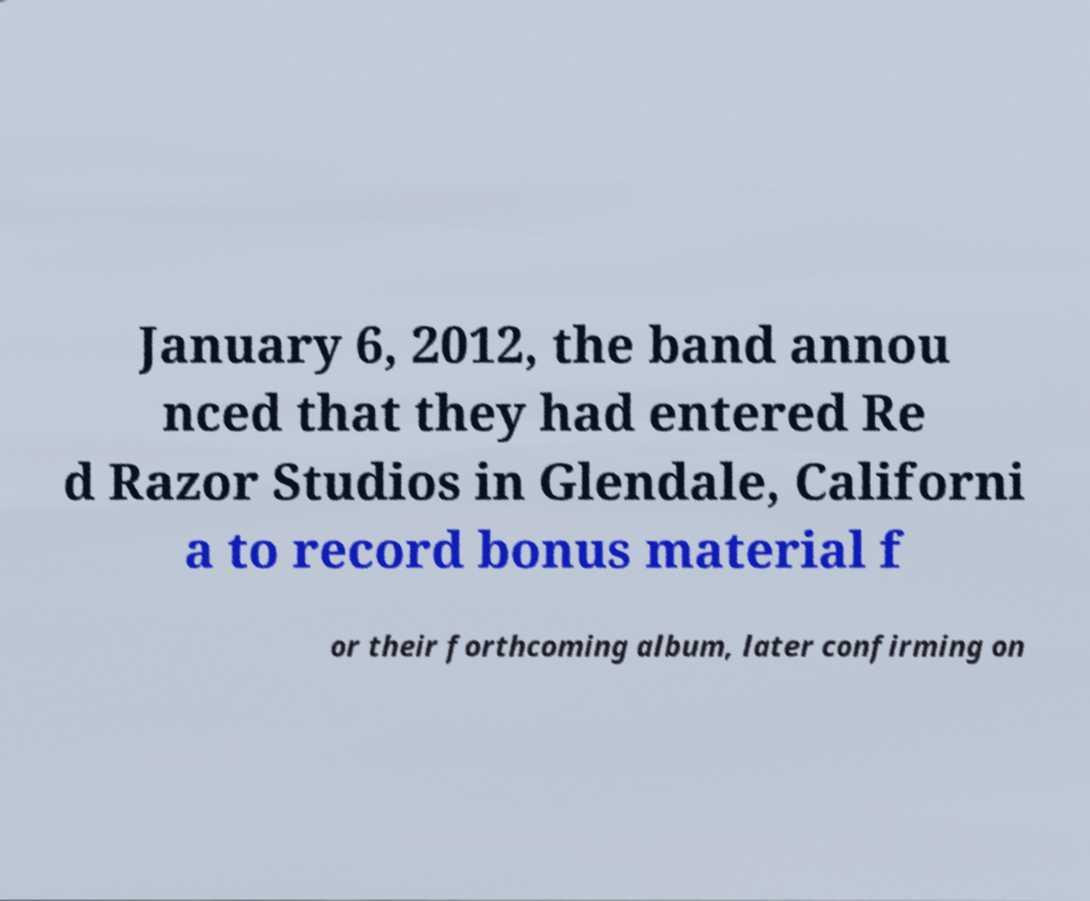Could you extract and type out the text from this image? January 6, 2012, the band annou nced that they had entered Re d Razor Studios in Glendale, Californi a to record bonus material f or their forthcoming album, later confirming on 